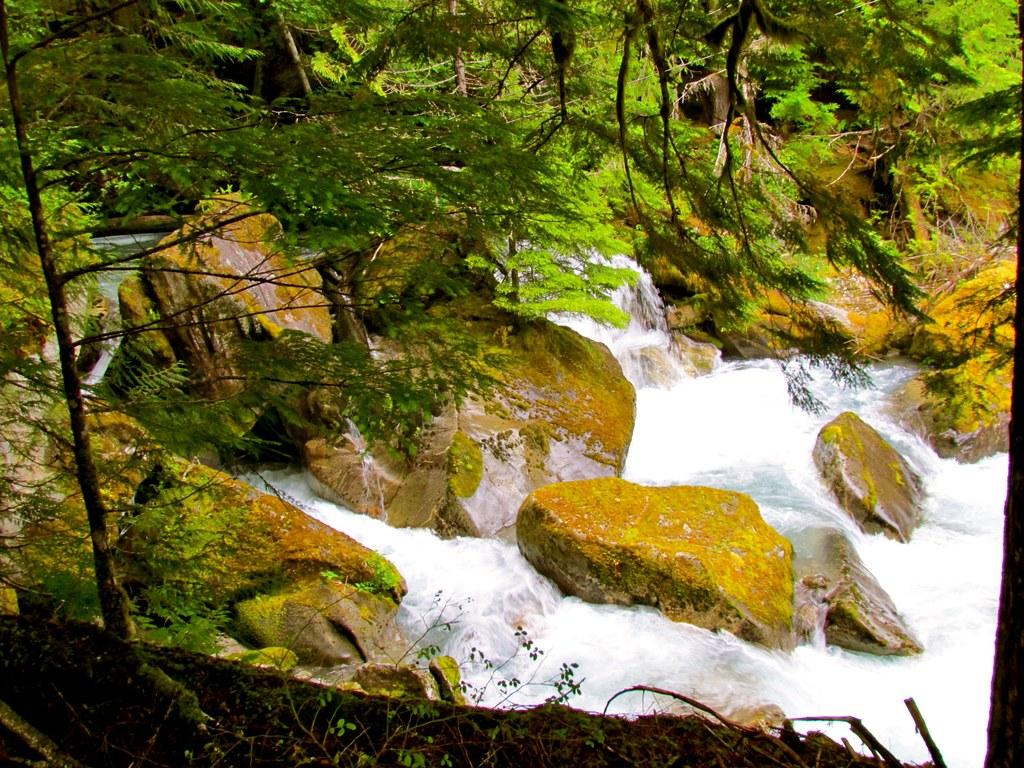What natural feature is located at the bottom of the image? There is a waterfall at the bottom of the image. What can be found near the waterfall? There are rocks near the waterfall. What type of vegetation is visible in the foreground of the image? There are trees in the foreground of the image. What type of vegetation is visible in the background of the image? There are trees in the background of the image. What is the name of the book on the page in the image? There is no book or page present in the image; it features a waterfall, rocks, and trees. 